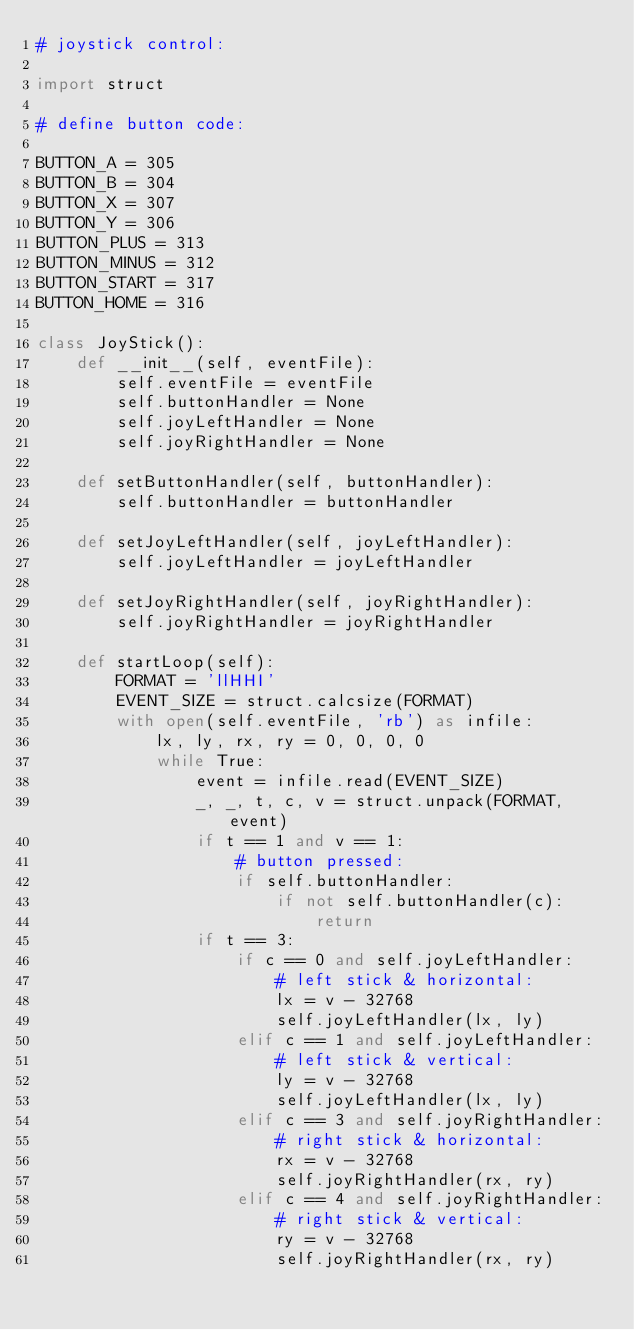<code> <loc_0><loc_0><loc_500><loc_500><_Python_># joystick control:

import struct

# define button code:

BUTTON_A = 305
BUTTON_B = 304
BUTTON_X = 307
BUTTON_Y = 306
BUTTON_PLUS = 313
BUTTON_MINUS = 312
BUTTON_START = 317
BUTTON_HOME = 316 

class JoyStick():
    def __init__(self, eventFile):
        self.eventFile = eventFile
        self.buttonHandler = None
        self.joyLeftHandler = None
        self.joyRightHandler = None

    def setButtonHandler(self, buttonHandler):
        self.buttonHandler = buttonHandler

    def setJoyLeftHandler(self, joyLeftHandler):
        self.joyLeftHandler = joyLeftHandler

    def setJoyRightHandler(self, joyRightHandler):
        self.joyRightHandler = joyRightHandler

    def startLoop(self):
        FORMAT = 'llHHI'
        EVENT_SIZE = struct.calcsize(FORMAT)
        with open(self.eventFile, 'rb') as infile:
            lx, ly, rx, ry = 0, 0, 0, 0
            while True:
                event = infile.read(EVENT_SIZE)
                _, _, t, c, v = struct.unpack(FORMAT, event)
                if t == 1 and v == 1:
                    # button pressed:
                    if self.buttonHandler:
                        if not self.buttonHandler(c):
                            return
                if t == 3:
                    if c == 0 and self.joyLeftHandler:
                        # left stick & horizontal:
                        lx = v - 32768
                        self.joyLeftHandler(lx, ly)
                    elif c == 1 and self.joyLeftHandler:
                        # left stick & vertical:
                        ly = v - 32768
                        self.joyLeftHandler(lx, ly)
                    elif c == 3 and self.joyRightHandler:
                        # right stick & horizontal:
                        rx = v - 32768
                        self.joyRightHandler(rx, ry)
                    elif c == 4 and self.joyRightHandler:
                        # right stick & vertical:
                        ry = v - 32768
                        self.joyRightHandler(rx, ry)
</code> 